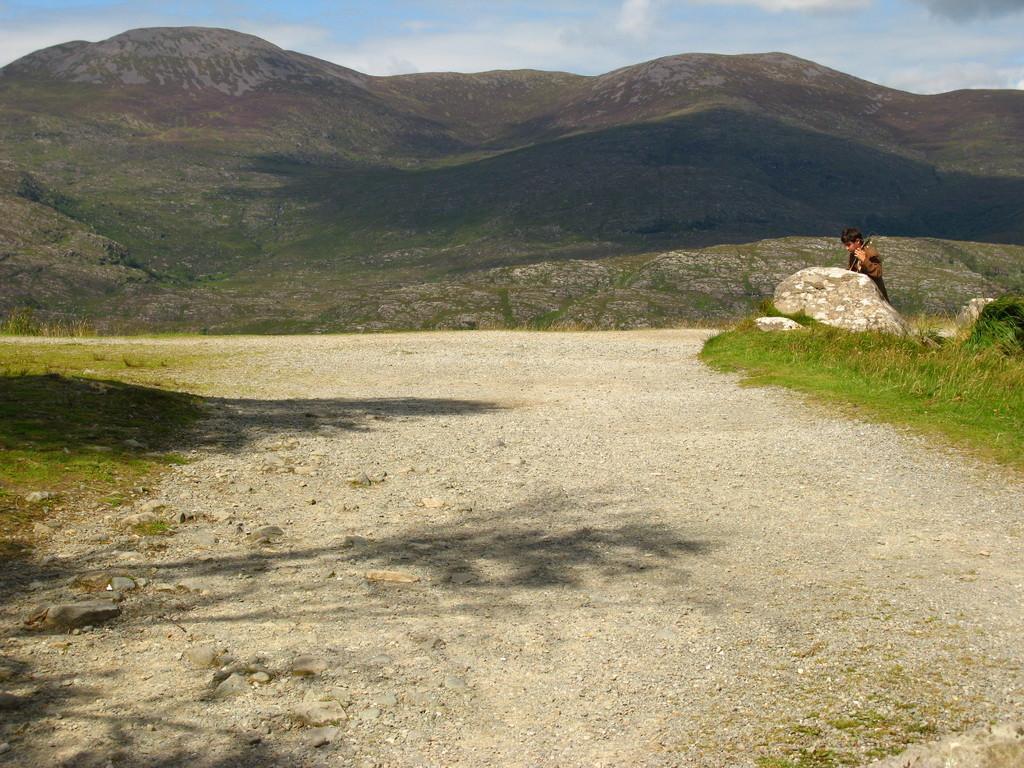Could you give a brief overview of what you see in this image? In the background of the image mountains are there. On the left side of the image grass is present. On the right side of the image a person and a rock is there. At the bottom of the image road is present. At the top of the image clouds are present in the sky. 